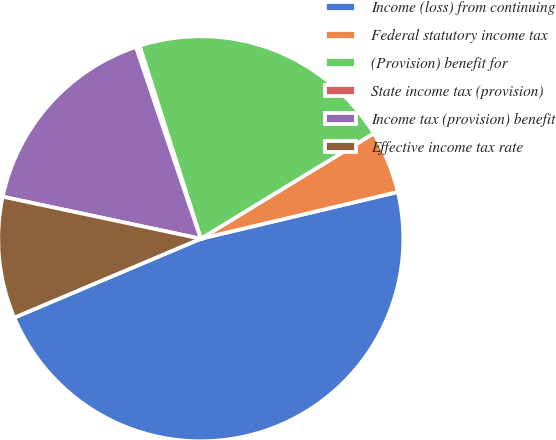<chart> <loc_0><loc_0><loc_500><loc_500><pie_chart><fcel>Income (loss) from continuing<fcel>Federal statutory income tax<fcel>(Provision) benefit for<fcel>State income tax (provision)<fcel>Income tax (provision) benefit<fcel>Effective income tax rate<nl><fcel>47.34%<fcel>5.0%<fcel>21.18%<fcel>0.3%<fcel>16.48%<fcel>9.7%<nl></chart> 